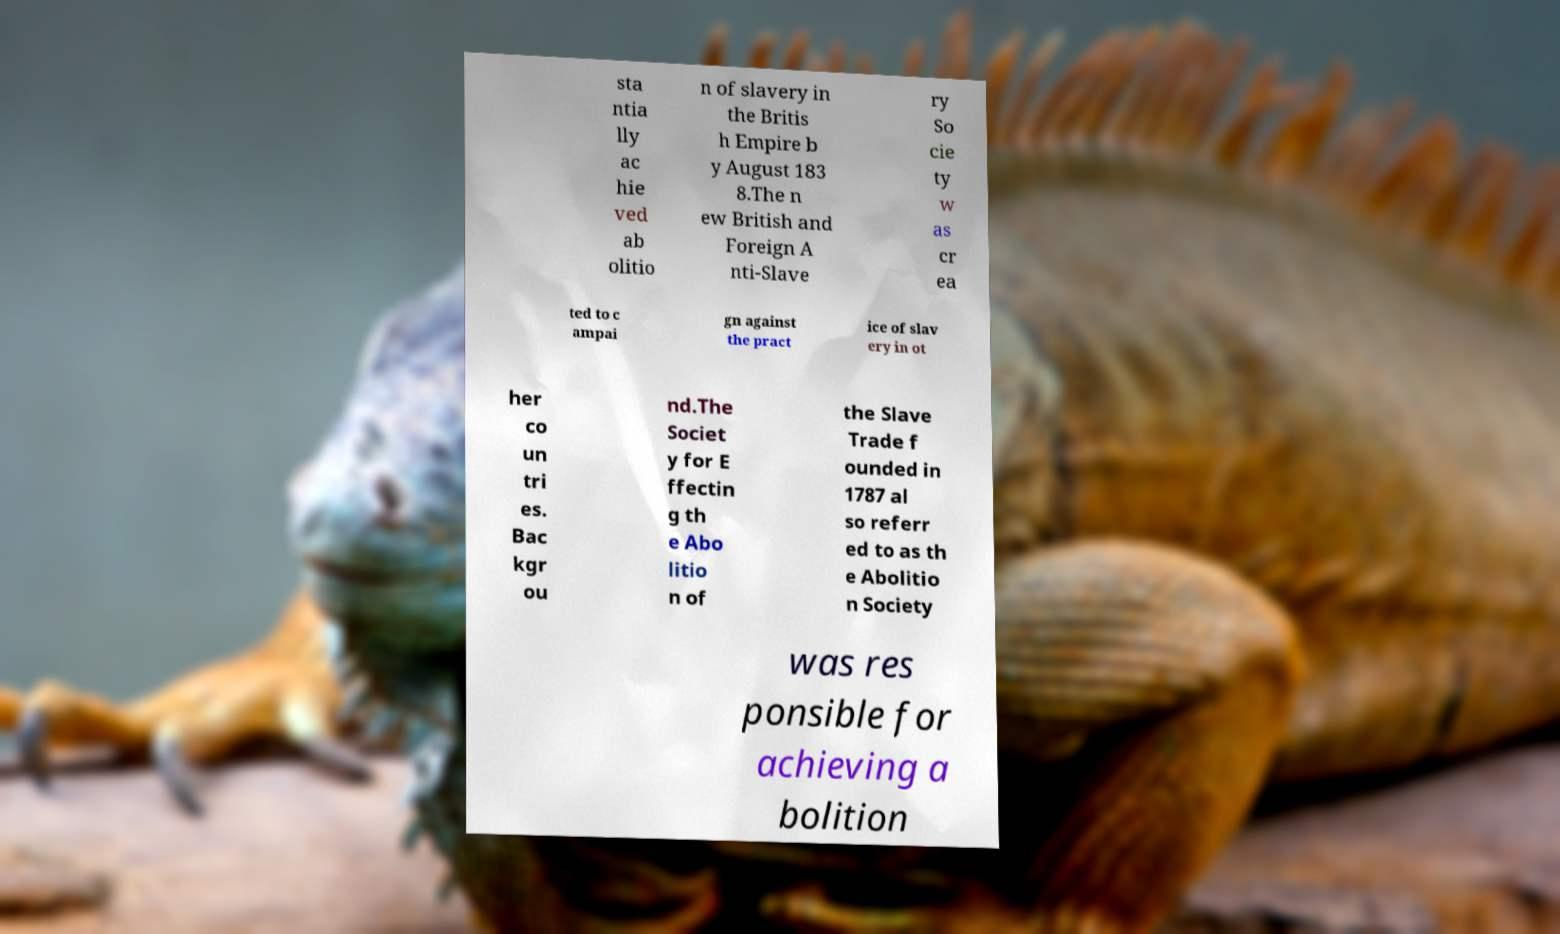Please read and relay the text visible in this image. What does it say? sta ntia lly ac hie ved ab olitio n of slavery in the Britis h Empire b y August 183 8.The n ew British and Foreign A nti-Slave ry So cie ty w as cr ea ted to c ampai gn against the pract ice of slav ery in ot her co un tri es. Bac kgr ou nd.The Societ y for E ffectin g th e Abo litio n of the Slave Trade f ounded in 1787 al so referr ed to as th e Abolitio n Society was res ponsible for achieving a bolition 